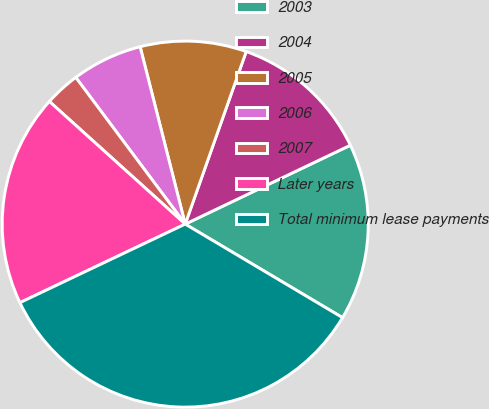Convert chart. <chart><loc_0><loc_0><loc_500><loc_500><pie_chart><fcel>2003<fcel>2004<fcel>2005<fcel>2006<fcel>2007<fcel>Later years<fcel>Total minimum lease payments<nl><fcel>15.63%<fcel>12.5%<fcel>9.37%<fcel>6.24%<fcel>3.11%<fcel>18.75%<fcel>34.4%<nl></chart> 